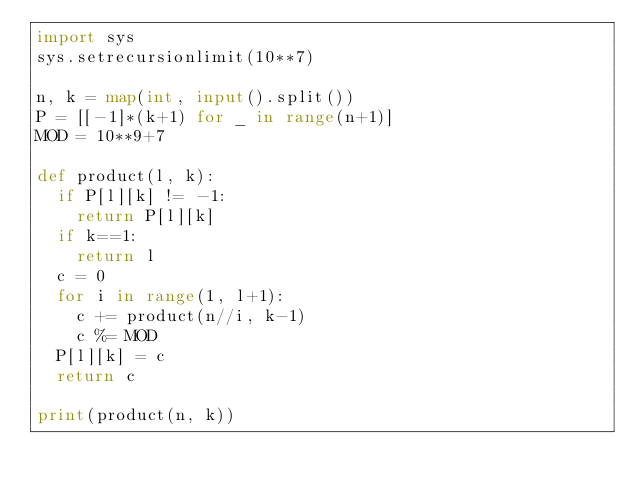<code> <loc_0><loc_0><loc_500><loc_500><_Python_>import sys
sys.setrecursionlimit(10**7)

n, k = map(int, input().split())
P = [[-1]*(k+1) for _ in range(n+1)]
MOD = 10**9+7

def product(l, k):
  if P[l][k] != -1:
    return P[l][k]
  if k==1:
    return l
  c = 0
  for i in range(1, l+1):
    c += product(n//i, k-1)
    c %= MOD
  P[l][k] = c
  return c

print(product(n, k))</code> 